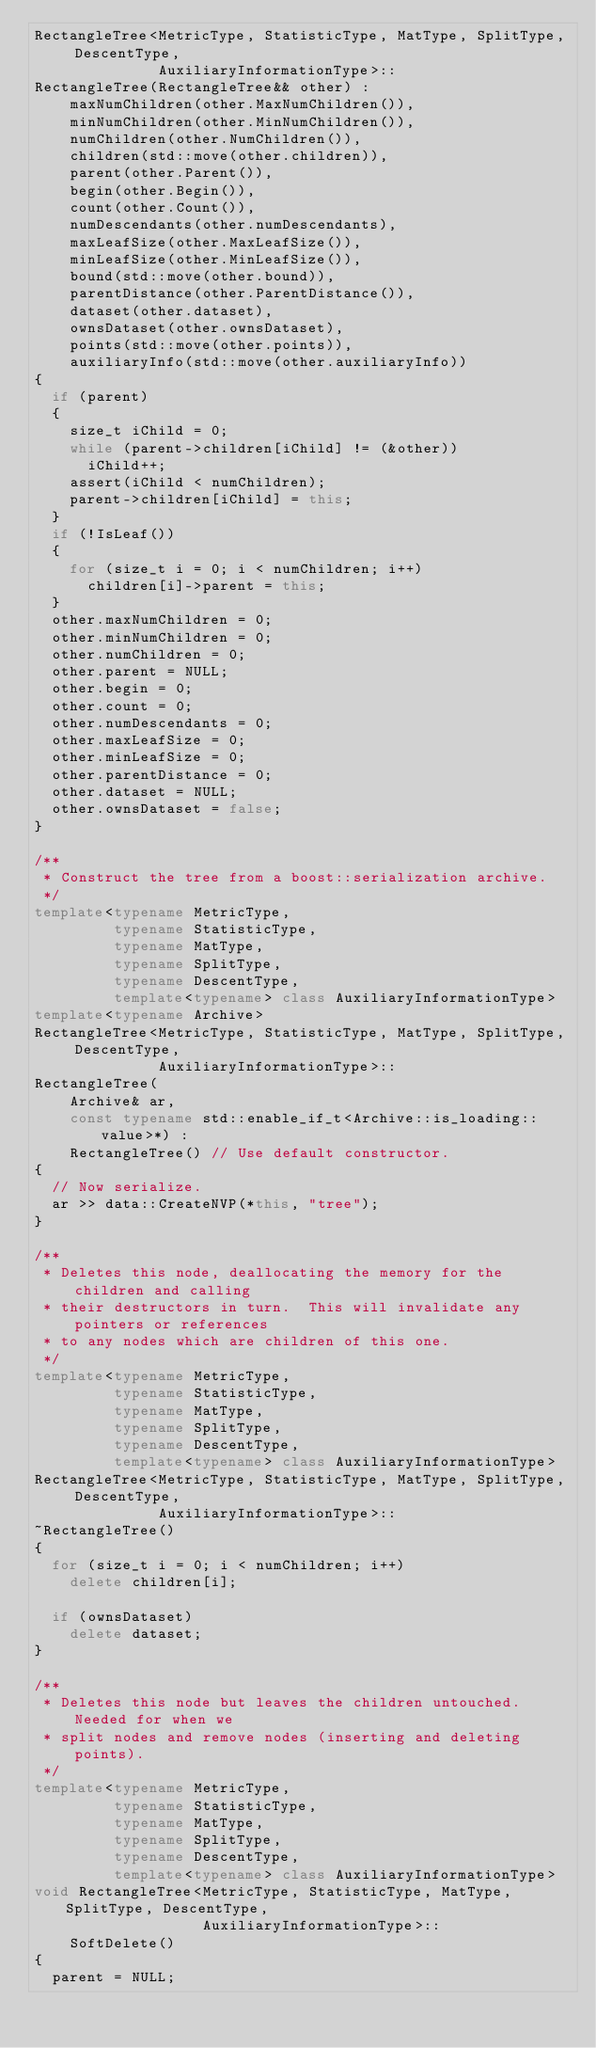Convert code to text. <code><loc_0><loc_0><loc_500><loc_500><_C++_>RectangleTree<MetricType, StatisticType, MatType, SplitType, DescentType,
              AuxiliaryInformationType>::
RectangleTree(RectangleTree&& other) :
    maxNumChildren(other.MaxNumChildren()),
    minNumChildren(other.MinNumChildren()),
    numChildren(other.NumChildren()),
    children(std::move(other.children)),
    parent(other.Parent()),
    begin(other.Begin()),
    count(other.Count()),
    numDescendants(other.numDescendants),
    maxLeafSize(other.MaxLeafSize()),
    minLeafSize(other.MinLeafSize()),
    bound(std::move(other.bound)),
    parentDistance(other.ParentDistance()),
    dataset(other.dataset),
    ownsDataset(other.ownsDataset),
    points(std::move(other.points)),
    auxiliaryInfo(std::move(other.auxiliaryInfo))
{
  if (parent)
  {
    size_t iChild = 0;
    while (parent->children[iChild] != (&other))
      iChild++;
    assert(iChild < numChildren);
    parent->children[iChild] = this;
  }
  if (!IsLeaf())
  {
    for (size_t i = 0; i < numChildren; i++)
      children[i]->parent = this;
  }
  other.maxNumChildren = 0;
  other.minNumChildren = 0;
  other.numChildren = 0;
  other.parent = NULL;
  other.begin = 0;
  other.count = 0;
  other.numDescendants = 0;
  other.maxLeafSize = 0;
  other.minLeafSize = 0;
  other.parentDistance = 0;
  other.dataset = NULL;
  other.ownsDataset = false;
}

/**
 * Construct the tree from a boost::serialization archive.
 */
template<typename MetricType,
         typename StatisticType,
         typename MatType,
         typename SplitType,
         typename DescentType,
         template<typename> class AuxiliaryInformationType>
template<typename Archive>
RectangleTree<MetricType, StatisticType, MatType, SplitType, DescentType,
              AuxiliaryInformationType>::
RectangleTree(
    Archive& ar,
    const typename std::enable_if_t<Archive::is_loading::value>*) :
    RectangleTree() // Use default constructor.
{
  // Now serialize.
  ar >> data::CreateNVP(*this, "tree");
}

/**
 * Deletes this node, deallocating the memory for the children and calling
 * their destructors in turn.  This will invalidate any pointers or references
 * to any nodes which are children of this one.
 */
template<typename MetricType,
         typename StatisticType,
         typename MatType,
         typename SplitType,
         typename DescentType,
         template<typename> class AuxiliaryInformationType>
RectangleTree<MetricType, StatisticType, MatType, SplitType, DescentType,
              AuxiliaryInformationType>::
~RectangleTree()
{
  for (size_t i = 0; i < numChildren; i++)
    delete children[i];

  if (ownsDataset)
    delete dataset;
}

/**
 * Deletes this node but leaves the children untouched.  Needed for when we
 * split nodes and remove nodes (inserting and deleting points).
 */
template<typename MetricType,
         typename StatisticType,
         typename MatType,
         typename SplitType,
         typename DescentType,
         template<typename> class AuxiliaryInformationType>
void RectangleTree<MetricType, StatisticType, MatType, SplitType, DescentType,
                   AuxiliaryInformationType>::
    SoftDelete()
{
  parent = NULL;
</code> 